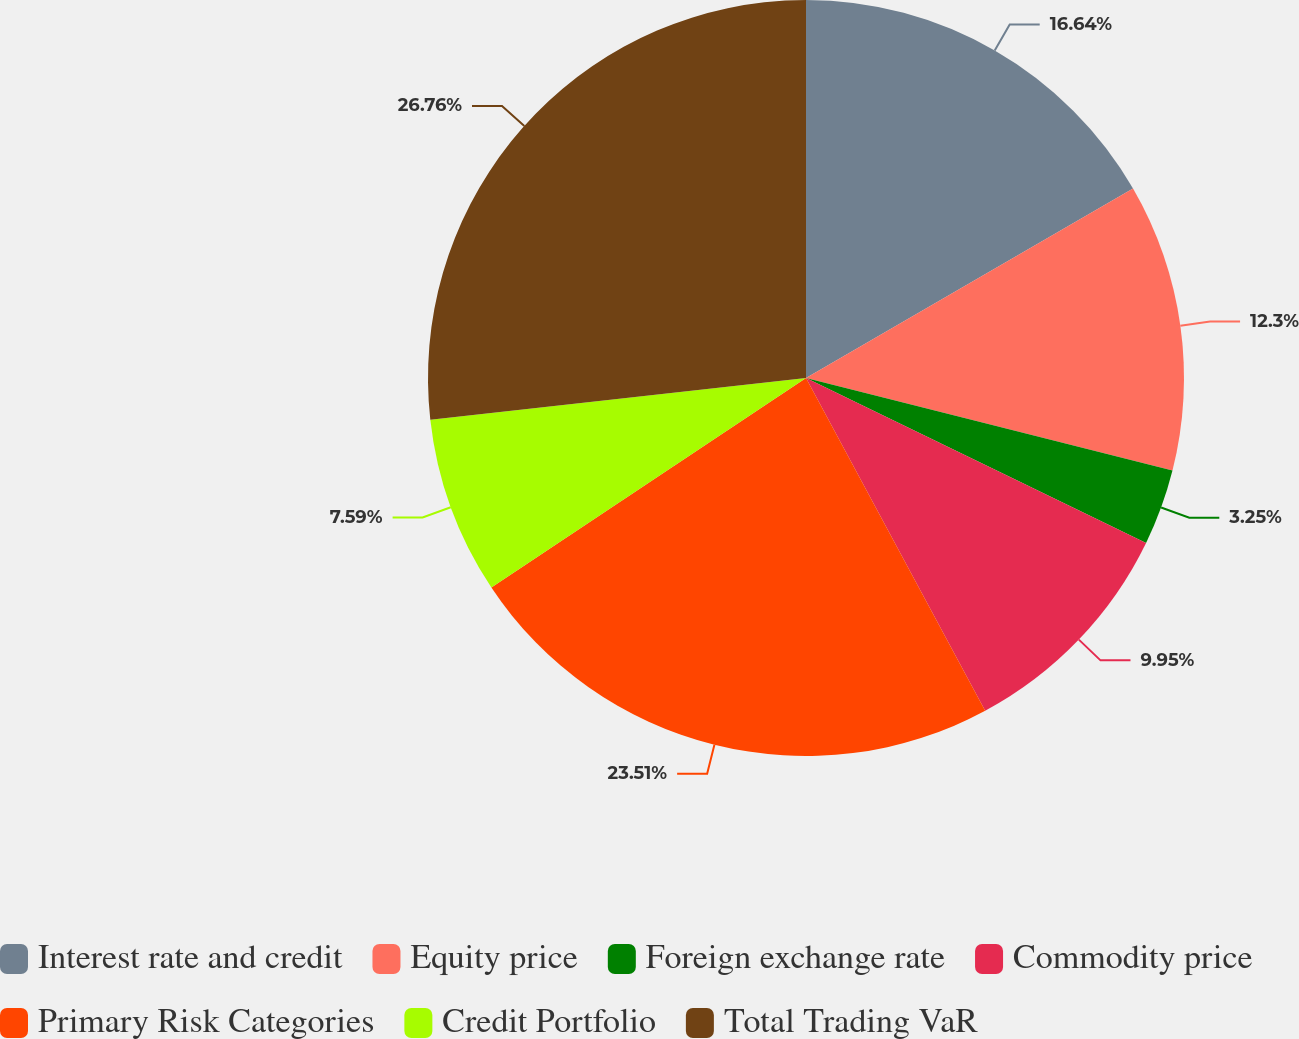Convert chart to OTSL. <chart><loc_0><loc_0><loc_500><loc_500><pie_chart><fcel>Interest rate and credit<fcel>Equity price<fcel>Foreign exchange rate<fcel>Commodity price<fcel>Primary Risk Categories<fcel>Credit Portfolio<fcel>Total Trading VaR<nl><fcel>16.64%<fcel>12.3%<fcel>3.25%<fcel>9.95%<fcel>23.51%<fcel>7.59%<fcel>26.76%<nl></chart> 